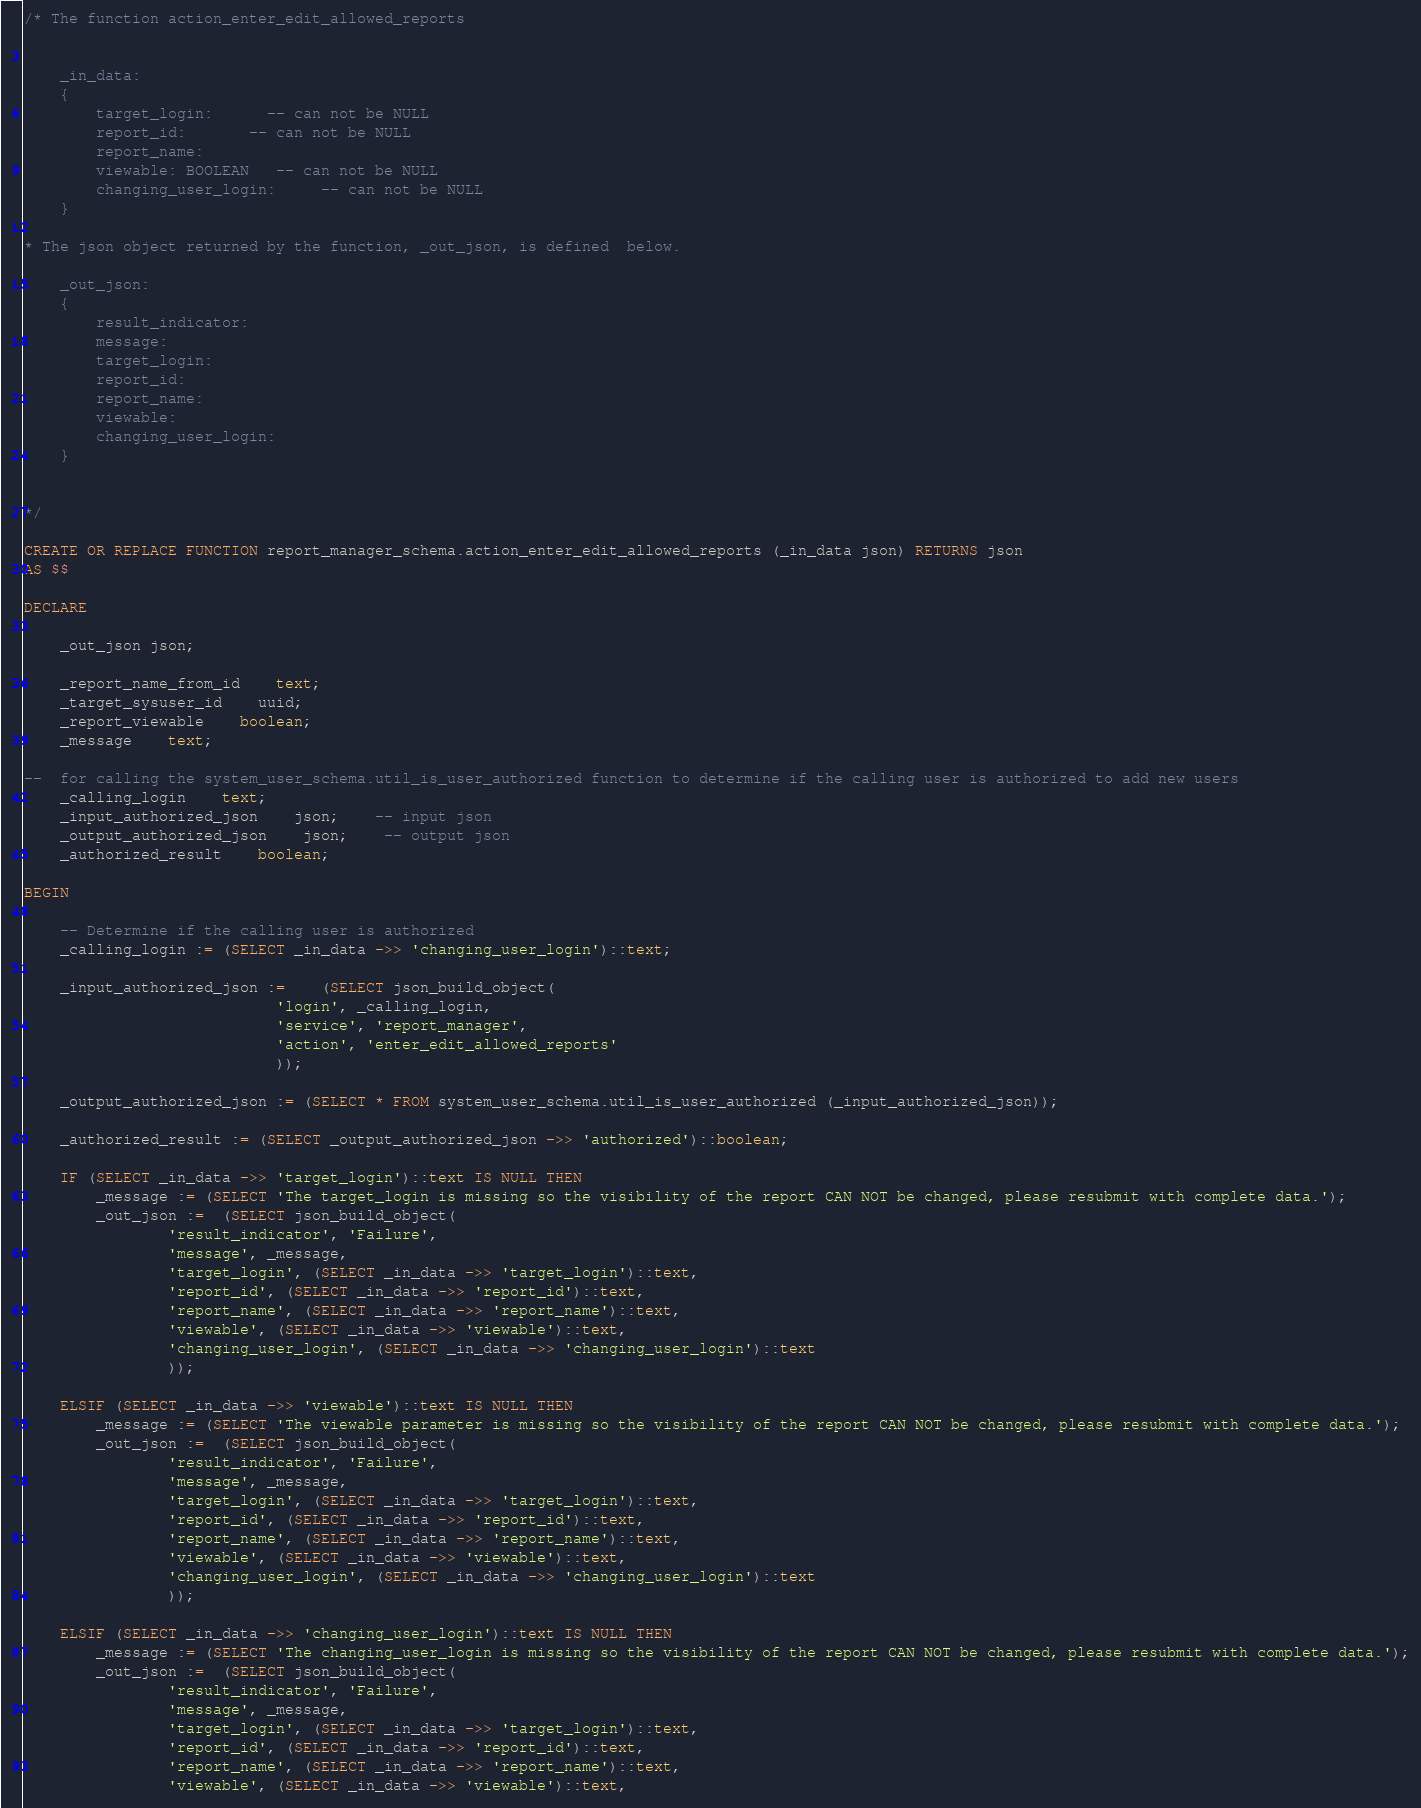Convert code to text. <code><loc_0><loc_0><loc_500><loc_500><_SQL_>/* The function action_enter_edit_allowed_reports


	_in_data:	
	{
		target_login:      -- can not be NULL
		report_id:       -- can not be NULL
		report_name:
		viewable: BOOLEAN   -- can not be NULL
		changing_user_login:     -- can not be NULL
	}
			
* The json object returned by the function, _out_json, is defined  below.

	_out_json:	
	{
		result_indicator:
		message:
		target_login:
		report_id:
		report_name:
		viewable:
		changing_user_login:
	}
				

*/

CREATE OR REPLACE FUNCTION report_manager_schema.action_enter_edit_allowed_reports (_in_data json) RETURNS json
AS $$

DECLARE
		
	_out_json json;
	
	_report_name_from_id	text;
	_target_sysuser_id	uuid;
	_report_viewable	boolean;
	_message	text;
	
--	for calling the system_user_schema.util_is_user_authorized function to determine if the calling user is authorized to add new users
	_calling_login	text;
	_input_authorized_json	json;	-- input json
	_output_authorized_json	json;	-- output json  
	_authorized_result	boolean;
	
BEGIN

	-- Determine if the calling user is authorized
	_calling_login := (SELECT _in_data ->> 'changing_user_login')::text;
	
	_input_authorized_json :=	(SELECT json_build_object(
							'login', _calling_login,
							'service', 'report_manager',
							'action', 'enter_edit_allowed_reports'
							));
	
	_output_authorized_json := (SELECT * FROM system_user_schema.util_is_user_authorized (_input_authorized_json));
	
	_authorized_result := (SELECT _output_authorized_json ->> 'authorized')::boolean;

    IF (SELECT _in_data ->> 'target_login')::text IS NULL THEN 
        _message := (SELECT 'The target_login is missing so the visibility of the report CAN NOT be changed, please resubmit with complete data.');
        _out_json :=  (SELECT json_build_object(
                'result_indicator', 'Failure',
                'message', _message,
                'target_login', (SELECT _in_data ->> 'target_login')::text,
                'report_id', (SELECT _in_data ->> 'report_id')::text,
                'report_name', (SELECT _in_data ->> 'report_name')::text,
                'viewable', (SELECT _in_data ->> 'viewable')::text,
                'changing_user_login', (SELECT _in_data ->> 'changing_user_login')::text
                ));		
       
    ELSIF (SELECT _in_data ->> 'viewable')::text IS NULL THEN  
        _message := (SELECT 'The viewable parameter is missing so the visibility of the report CAN NOT be changed, please resubmit with complete data.');
        _out_json :=  (SELECT json_build_object(
                'result_indicator', 'Failure',
                'message', _message,
                'target_login', (SELECT _in_data ->> 'target_login')::text,
                'report_id', (SELECT _in_data ->> 'report_id')::text,
                'report_name', (SELECT _in_data ->> 'report_name')::text,
                'viewable', (SELECT _in_data ->> 'viewable')::text,
                'changing_user_login', (SELECT _in_data ->> 'changing_user_login')::text
                ));		
                
    ELSIF (SELECT _in_data ->> 'changing_user_login')::text IS NULL THEN  
        _message := (SELECT 'The changing_user_login is missing so the visibility of the report CAN NOT be changed, please resubmit with complete data.');
        _out_json :=  (SELECT json_build_object(
                'result_indicator', 'Failure',
                'message', _message,
                'target_login', (SELECT _in_data ->> 'target_login')::text,
                'report_id', (SELECT _in_data ->> 'report_id')::text,
                'report_name', (SELECT _in_data ->> 'report_name')::text,
                'viewable', (SELECT _in_data ->> 'viewable')::text,</code> 